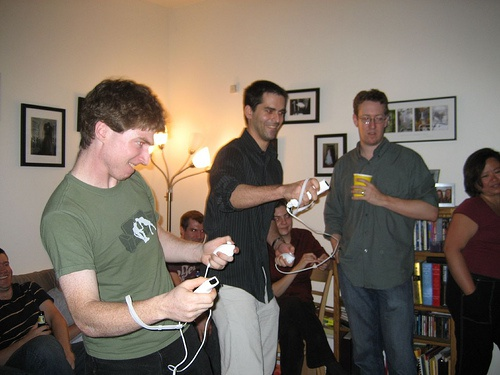Describe the objects in this image and their specific colors. I can see people in gray, lightpink, and black tones, people in gray, black, and purple tones, people in gray, black, and darkgray tones, people in gray, black, maroon, and brown tones, and people in gray, black, and maroon tones in this image. 